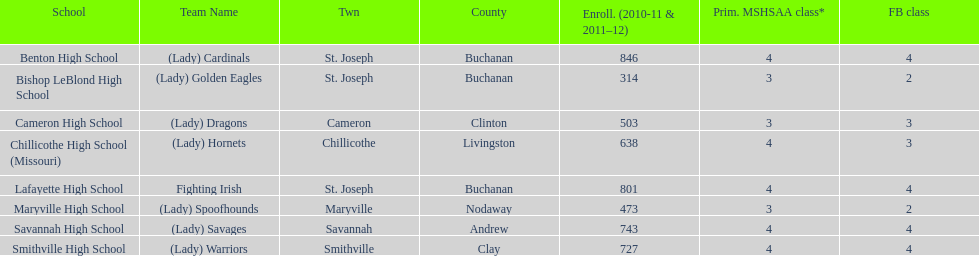Which school has the largest enrollment? Benton High School. 